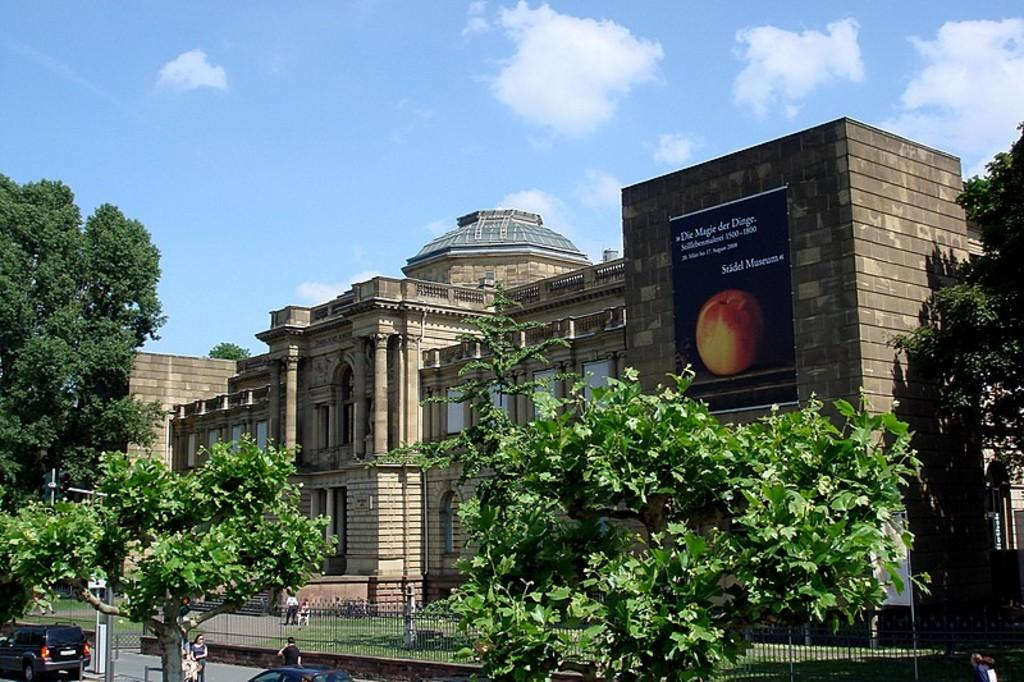What type of structure is in the image? There is a building in the image. What feature can be seen on the building? The building has windows. What is attached to the building? There is a poster on the building. What type of vegetation is in the image? There are trees in the image. What is visible in the background of the image? The sky is visible in the image. What type of reaction can be seen from the person holding the bucket in the image? There is no person holding a bucket in the image. 